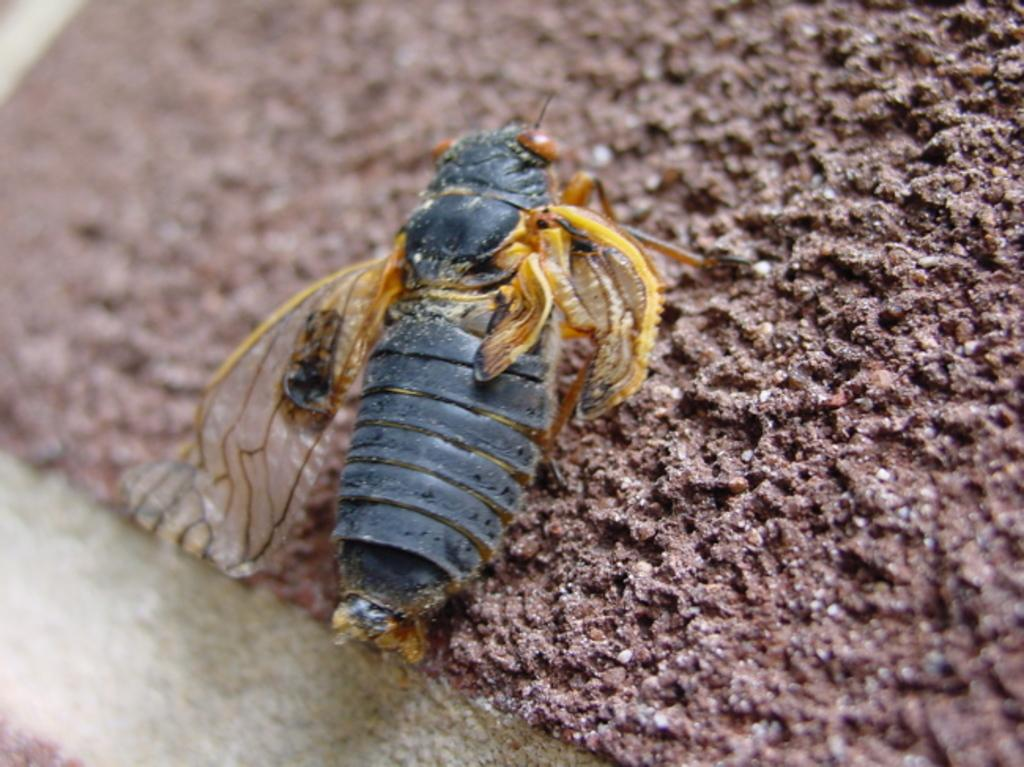What type of creature can be seen in the image? There is an insect in the image. What is the insect's location in the image? The insect is on a rough surface. Can you describe the color of the surface the insect is on? The surface is brown in color. How many passengers can be seen in the image? There are no passengers present in the image, as it features an insect on a rough, brown surface. 